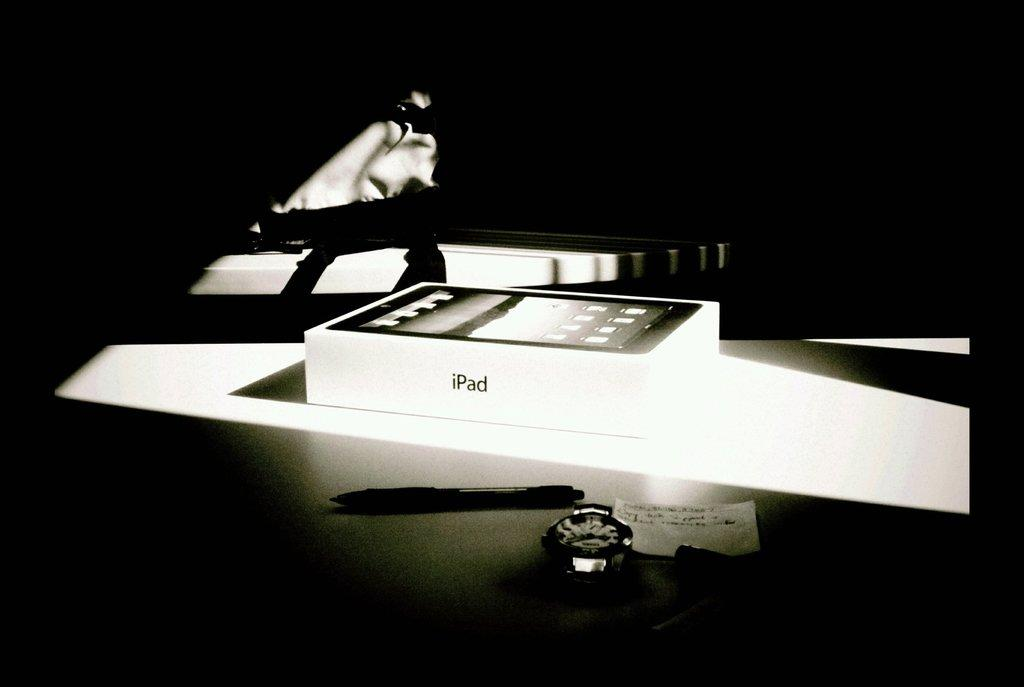<image>
Relay a brief, clear account of the picture shown. a lit up iPad box on a white surface 